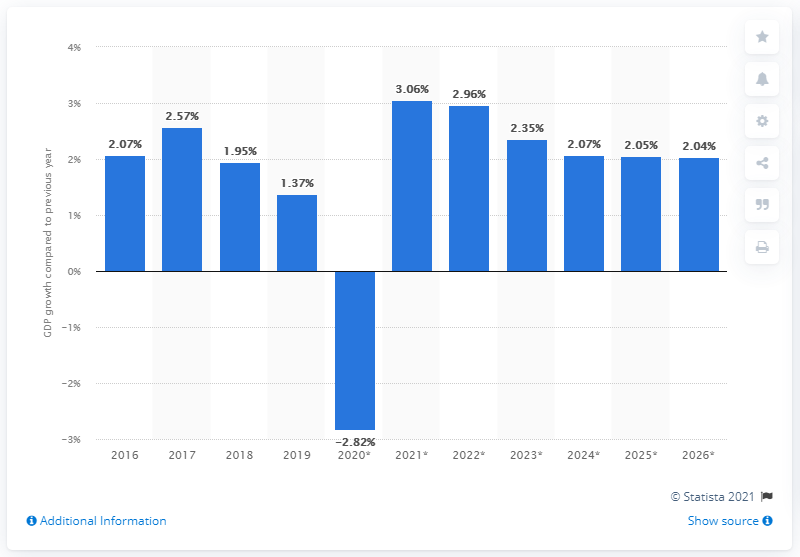Draw attention to some important aspects in this diagram. In 2019, Sweden's gross domestic product (GDP) grew by 1.37%. 